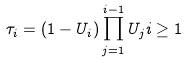<formula> <loc_0><loc_0><loc_500><loc_500>\tau _ { i } = ( 1 - U _ { i } ) \prod _ { j = 1 } ^ { i - 1 } U _ { j } i \geq 1</formula> 